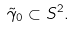<formula> <loc_0><loc_0><loc_500><loc_500>\tilde { \gamma } _ { 0 } \subset S ^ { 2 } .</formula> 